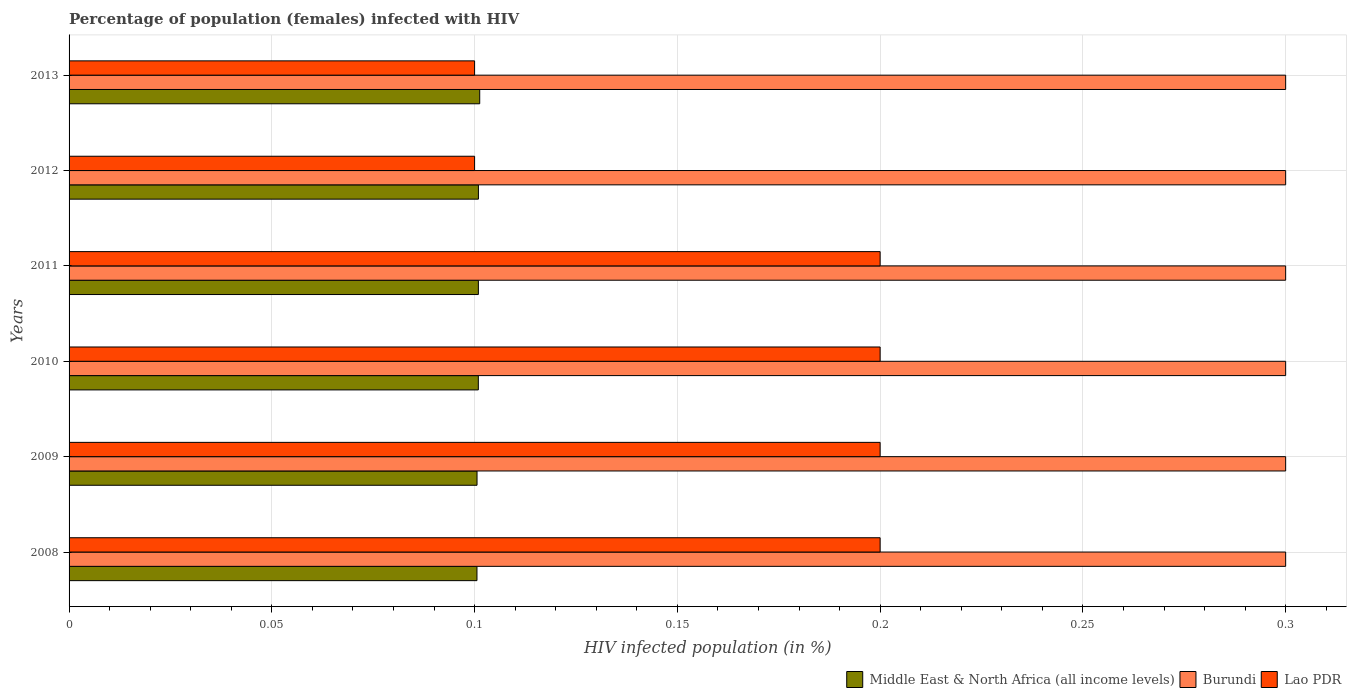Are the number of bars per tick equal to the number of legend labels?
Give a very brief answer. Yes. Are the number of bars on each tick of the Y-axis equal?
Your answer should be compact. Yes. In how many cases, is the number of bars for a given year not equal to the number of legend labels?
Offer a very short reply. 0. What is the percentage of HIV infected female population in Lao PDR in 2011?
Make the answer very short. 0.2. Across all years, what is the maximum percentage of HIV infected female population in Middle East & North Africa (all income levels)?
Your answer should be very brief. 0.1. Across all years, what is the minimum percentage of HIV infected female population in Middle East & North Africa (all income levels)?
Keep it short and to the point. 0.1. In which year was the percentage of HIV infected female population in Lao PDR maximum?
Make the answer very short. 2008. What is the total percentage of HIV infected female population in Middle East & North Africa (all income levels) in the graph?
Make the answer very short. 0.61. What is the difference between the percentage of HIV infected female population in Burundi in 2011 and the percentage of HIV infected female population in Lao PDR in 2008?
Ensure brevity in your answer.  0.1. What is the average percentage of HIV infected female population in Middle East & North Africa (all income levels) per year?
Give a very brief answer. 0.1. In the year 2010, what is the difference between the percentage of HIV infected female population in Burundi and percentage of HIV infected female population in Middle East & North Africa (all income levels)?
Offer a very short reply. 0.2. What is the ratio of the percentage of HIV infected female population in Middle East & North Africa (all income levels) in 2010 to that in 2011?
Make the answer very short. 1. Is the percentage of HIV infected female population in Middle East & North Africa (all income levels) in 2010 less than that in 2012?
Your answer should be compact. Yes. In how many years, is the percentage of HIV infected female population in Lao PDR greater than the average percentage of HIV infected female population in Lao PDR taken over all years?
Offer a terse response. 4. Is the sum of the percentage of HIV infected female population in Middle East & North Africa (all income levels) in 2008 and 2013 greater than the maximum percentage of HIV infected female population in Lao PDR across all years?
Provide a succinct answer. Yes. What does the 1st bar from the top in 2012 represents?
Your answer should be very brief. Lao PDR. What does the 3rd bar from the bottom in 2013 represents?
Make the answer very short. Lao PDR. Are the values on the major ticks of X-axis written in scientific E-notation?
Provide a succinct answer. No. Does the graph contain any zero values?
Offer a very short reply. No. Where does the legend appear in the graph?
Your answer should be compact. Bottom right. What is the title of the graph?
Make the answer very short. Percentage of population (females) infected with HIV. What is the label or title of the X-axis?
Your answer should be compact. HIV infected population (in %). What is the HIV infected population (in %) in Middle East & North Africa (all income levels) in 2008?
Provide a short and direct response. 0.1. What is the HIV infected population (in %) in Middle East & North Africa (all income levels) in 2009?
Your response must be concise. 0.1. What is the HIV infected population (in %) of Middle East & North Africa (all income levels) in 2010?
Provide a short and direct response. 0.1. What is the HIV infected population (in %) in Lao PDR in 2010?
Make the answer very short. 0.2. What is the HIV infected population (in %) in Middle East & North Africa (all income levels) in 2011?
Make the answer very short. 0.1. What is the HIV infected population (in %) of Lao PDR in 2011?
Provide a succinct answer. 0.2. What is the HIV infected population (in %) in Middle East & North Africa (all income levels) in 2012?
Ensure brevity in your answer.  0.1. What is the HIV infected population (in %) of Middle East & North Africa (all income levels) in 2013?
Offer a terse response. 0.1. What is the HIV infected population (in %) of Burundi in 2013?
Provide a succinct answer. 0.3. Across all years, what is the maximum HIV infected population (in %) of Middle East & North Africa (all income levels)?
Your answer should be very brief. 0.1. Across all years, what is the minimum HIV infected population (in %) of Middle East & North Africa (all income levels)?
Give a very brief answer. 0.1. Across all years, what is the minimum HIV infected population (in %) of Burundi?
Keep it short and to the point. 0.3. Across all years, what is the minimum HIV infected population (in %) in Lao PDR?
Provide a short and direct response. 0.1. What is the total HIV infected population (in %) in Middle East & North Africa (all income levels) in the graph?
Provide a succinct answer. 0.61. What is the total HIV infected population (in %) in Lao PDR in the graph?
Offer a terse response. 1. What is the difference between the HIV infected population (in %) of Middle East & North Africa (all income levels) in 2008 and that in 2009?
Make the answer very short. -0. What is the difference between the HIV infected population (in %) in Burundi in 2008 and that in 2009?
Provide a short and direct response. 0. What is the difference between the HIV infected population (in %) in Middle East & North Africa (all income levels) in 2008 and that in 2010?
Your answer should be compact. -0. What is the difference between the HIV infected population (in %) in Burundi in 2008 and that in 2010?
Keep it short and to the point. 0. What is the difference between the HIV infected population (in %) of Lao PDR in 2008 and that in 2010?
Make the answer very short. 0. What is the difference between the HIV infected population (in %) of Middle East & North Africa (all income levels) in 2008 and that in 2011?
Make the answer very short. -0. What is the difference between the HIV infected population (in %) in Middle East & North Africa (all income levels) in 2008 and that in 2012?
Provide a succinct answer. -0. What is the difference between the HIV infected population (in %) in Lao PDR in 2008 and that in 2012?
Make the answer very short. 0.1. What is the difference between the HIV infected population (in %) in Middle East & North Africa (all income levels) in 2008 and that in 2013?
Your answer should be very brief. -0. What is the difference between the HIV infected population (in %) of Burundi in 2008 and that in 2013?
Give a very brief answer. 0. What is the difference between the HIV infected population (in %) of Lao PDR in 2008 and that in 2013?
Your answer should be very brief. 0.1. What is the difference between the HIV infected population (in %) in Middle East & North Africa (all income levels) in 2009 and that in 2010?
Make the answer very short. -0. What is the difference between the HIV infected population (in %) in Burundi in 2009 and that in 2010?
Ensure brevity in your answer.  0. What is the difference between the HIV infected population (in %) in Lao PDR in 2009 and that in 2010?
Give a very brief answer. 0. What is the difference between the HIV infected population (in %) of Middle East & North Africa (all income levels) in 2009 and that in 2011?
Your response must be concise. -0. What is the difference between the HIV infected population (in %) in Middle East & North Africa (all income levels) in 2009 and that in 2012?
Provide a succinct answer. -0. What is the difference between the HIV infected population (in %) in Burundi in 2009 and that in 2012?
Your answer should be compact. 0. What is the difference between the HIV infected population (in %) of Lao PDR in 2009 and that in 2012?
Provide a short and direct response. 0.1. What is the difference between the HIV infected population (in %) of Middle East & North Africa (all income levels) in 2009 and that in 2013?
Your answer should be compact. -0. What is the difference between the HIV infected population (in %) of Burundi in 2009 and that in 2013?
Offer a very short reply. 0. What is the difference between the HIV infected population (in %) of Lao PDR in 2009 and that in 2013?
Give a very brief answer. 0.1. What is the difference between the HIV infected population (in %) in Lao PDR in 2010 and that in 2011?
Provide a succinct answer. 0. What is the difference between the HIV infected population (in %) of Lao PDR in 2010 and that in 2012?
Offer a terse response. 0.1. What is the difference between the HIV infected population (in %) of Middle East & North Africa (all income levels) in 2010 and that in 2013?
Offer a terse response. -0. What is the difference between the HIV infected population (in %) in Burundi in 2010 and that in 2013?
Offer a terse response. 0. What is the difference between the HIV infected population (in %) in Lao PDR in 2011 and that in 2012?
Provide a short and direct response. 0.1. What is the difference between the HIV infected population (in %) of Middle East & North Africa (all income levels) in 2011 and that in 2013?
Your response must be concise. -0. What is the difference between the HIV infected population (in %) of Burundi in 2011 and that in 2013?
Offer a very short reply. 0. What is the difference between the HIV infected population (in %) of Lao PDR in 2011 and that in 2013?
Ensure brevity in your answer.  0.1. What is the difference between the HIV infected population (in %) in Middle East & North Africa (all income levels) in 2012 and that in 2013?
Your answer should be compact. -0. What is the difference between the HIV infected population (in %) in Lao PDR in 2012 and that in 2013?
Provide a succinct answer. 0. What is the difference between the HIV infected population (in %) of Middle East & North Africa (all income levels) in 2008 and the HIV infected population (in %) of Burundi in 2009?
Provide a succinct answer. -0.2. What is the difference between the HIV infected population (in %) of Middle East & North Africa (all income levels) in 2008 and the HIV infected population (in %) of Lao PDR in 2009?
Give a very brief answer. -0.1. What is the difference between the HIV infected population (in %) in Middle East & North Africa (all income levels) in 2008 and the HIV infected population (in %) in Burundi in 2010?
Make the answer very short. -0.2. What is the difference between the HIV infected population (in %) in Middle East & North Africa (all income levels) in 2008 and the HIV infected population (in %) in Lao PDR in 2010?
Offer a very short reply. -0.1. What is the difference between the HIV infected population (in %) of Middle East & North Africa (all income levels) in 2008 and the HIV infected population (in %) of Burundi in 2011?
Offer a very short reply. -0.2. What is the difference between the HIV infected population (in %) of Middle East & North Africa (all income levels) in 2008 and the HIV infected population (in %) of Lao PDR in 2011?
Give a very brief answer. -0.1. What is the difference between the HIV infected population (in %) in Burundi in 2008 and the HIV infected population (in %) in Lao PDR in 2011?
Your response must be concise. 0.1. What is the difference between the HIV infected population (in %) in Middle East & North Africa (all income levels) in 2008 and the HIV infected population (in %) in Burundi in 2012?
Offer a very short reply. -0.2. What is the difference between the HIV infected population (in %) of Middle East & North Africa (all income levels) in 2008 and the HIV infected population (in %) of Lao PDR in 2012?
Offer a terse response. 0. What is the difference between the HIV infected population (in %) of Middle East & North Africa (all income levels) in 2008 and the HIV infected population (in %) of Burundi in 2013?
Provide a short and direct response. -0.2. What is the difference between the HIV infected population (in %) of Middle East & North Africa (all income levels) in 2008 and the HIV infected population (in %) of Lao PDR in 2013?
Give a very brief answer. 0. What is the difference between the HIV infected population (in %) in Middle East & North Africa (all income levels) in 2009 and the HIV infected population (in %) in Burundi in 2010?
Your answer should be very brief. -0.2. What is the difference between the HIV infected population (in %) in Middle East & North Africa (all income levels) in 2009 and the HIV infected population (in %) in Lao PDR in 2010?
Make the answer very short. -0.1. What is the difference between the HIV infected population (in %) of Burundi in 2009 and the HIV infected population (in %) of Lao PDR in 2010?
Offer a very short reply. 0.1. What is the difference between the HIV infected population (in %) in Middle East & North Africa (all income levels) in 2009 and the HIV infected population (in %) in Burundi in 2011?
Make the answer very short. -0.2. What is the difference between the HIV infected population (in %) in Middle East & North Africa (all income levels) in 2009 and the HIV infected population (in %) in Lao PDR in 2011?
Your response must be concise. -0.1. What is the difference between the HIV infected population (in %) in Middle East & North Africa (all income levels) in 2009 and the HIV infected population (in %) in Burundi in 2012?
Give a very brief answer. -0.2. What is the difference between the HIV infected population (in %) of Middle East & North Africa (all income levels) in 2009 and the HIV infected population (in %) of Lao PDR in 2012?
Your answer should be compact. 0. What is the difference between the HIV infected population (in %) of Middle East & North Africa (all income levels) in 2009 and the HIV infected population (in %) of Burundi in 2013?
Offer a terse response. -0.2. What is the difference between the HIV infected population (in %) of Middle East & North Africa (all income levels) in 2009 and the HIV infected population (in %) of Lao PDR in 2013?
Your answer should be compact. 0. What is the difference between the HIV infected population (in %) in Burundi in 2009 and the HIV infected population (in %) in Lao PDR in 2013?
Your answer should be very brief. 0.2. What is the difference between the HIV infected population (in %) in Middle East & North Africa (all income levels) in 2010 and the HIV infected population (in %) in Burundi in 2011?
Give a very brief answer. -0.2. What is the difference between the HIV infected population (in %) in Middle East & North Africa (all income levels) in 2010 and the HIV infected population (in %) in Lao PDR in 2011?
Offer a very short reply. -0.1. What is the difference between the HIV infected population (in %) of Burundi in 2010 and the HIV infected population (in %) of Lao PDR in 2011?
Give a very brief answer. 0.1. What is the difference between the HIV infected population (in %) in Middle East & North Africa (all income levels) in 2010 and the HIV infected population (in %) in Burundi in 2012?
Provide a short and direct response. -0.2. What is the difference between the HIV infected population (in %) of Middle East & North Africa (all income levels) in 2010 and the HIV infected population (in %) of Lao PDR in 2012?
Provide a short and direct response. 0. What is the difference between the HIV infected population (in %) in Middle East & North Africa (all income levels) in 2010 and the HIV infected population (in %) in Burundi in 2013?
Provide a short and direct response. -0.2. What is the difference between the HIV infected population (in %) in Middle East & North Africa (all income levels) in 2010 and the HIV infected population (in %) in Lao PDR in 2013?
Provide a succinct answer. 0. What is the difference between the HIV infected population (in %) of Middle East & North Africa (all income levels) in 2011 and the HIV infected population (in %) of Burundi in 2012?
Offer a very short reply. -0.2. What is the difference between the HIV infected population (in %) of Middle East & North Africa (all income levels) in 2011 and the HIV infected population (in %) of Lao PDR in 2012?
Ensure brevity in your answer.  0. What is the difference between the HIV infected population (in %) in Middle East & North Africa (all income levels) in 2011 and the HIV infected population (in %) in Burundi in 2013?
Your response must be concise. -0.2. What is the difference between the HIV infected population (in %) in Middle East & North Africa (all income levels) in 2011 and the HIV infected population (in %) in Lao PDR in 2013?
Offer a very short reply. 0. What is the difference between the HIV infected population (in %) of Burundi in 2011 and the HIV infected population (in %) of Lao PDR in 2013?
Provide a succinct answer. 0.2. What is the difference between the HIV infected population (in %) of Middle East & North Africa (all income levels) in 2012 and the HIV infected population (in %) of Burundi in 2013?
Your answer should be compact. -0.2. What is the difference between the HIV infected population (in %) of Middle East & North Africa (all income levels) in 2012 and the HIV infected population (in %) of Lao PDR in 2013?
Make the answer very short. 0. What is the average HIV infected population (in %) in Middle East & North Africa (all income levels) per year?
Provide a short and direct response. 0.1. What is the average HIV infected population (in %) in Lao PDR per year?
Provide a short and direct response. 0.17. In the year 2008, what is the difference between the HIV infected population (in %) in Middle East & North Africa (all income levels) and HIV infected population (in %) in Burundi?
Offer a terse response. -0.2. In the year 2008, what is the difference between the HIV infected population (in %) of Middle East & North Africa (all income levels) and HIV infected population (in %) of Lao PDR?
Provide a short and direct response. -0.1. In the year 2009, what is the difference between the HIV infected population (in %) of Middle East & North Africa (all income levels) and HIV infected population (in %) of Burundi?
Provide a short and direct response. -0.2. In the year 2009, what is the difference between the HIV infected population (in %) of Middle East & North Africa (all income levels) and HIV infected population (in %) of Lao PDR?
Provide a short and direct response. -0.1. In the year 2009, what is the difference between the HIV infected population (in %) in Burundi and HIV infected population (in %) in Lao PDR?
Make the answer very short. 0.1. In the year 2010, what is the difference between the HIV infected population (in %) of Middle East & North Africa (all income levels) and HIV infected population (in %) of Burundi?
Give a very brief answer. -0.2. In the year 2010, what is the difference between the HIV infected population (in %) in Middle East & North Africa (all income levels) and HIV infected population (in %) in Lao PDR?
Keep it short and to the point. -0.1. In the year 2011, what is the difference between the HIV infected population (in %) of Middle East & North Africa (all income levels) and HIV infected population (in %) of Burundi?
Ensure brevity in your answer.  -0.2. In the year 2011, what is the difference between the HIV infected population (in %) of Middle East & North Africa (all income levels) and HIV infected population (in %) of Lao PDR?
Keep it short and to the point. -0.1. In the year 2011, what is the difference between the HIV infected population (in %) of Burundi and HIV infected population (in %) of Lao PDR?
Offer a very short reply. 0.1. In the year 2012, what is the difference between the HIV infected population (in %) in Middle East & North Africa (all income levels) and HIV infected population (in %) in Burundi?
Ensure brevity in your answer.  -0.2. In the year 2012, what is the difference between the HIV infected population (in %) in Middle East & North Africa (all income levels) and HIV infected population (in %) in Lao PDR?
Keep it short and to the point. 0. In the year 2013, what is the difference between the HIV infected population (in %) of Middle East & North Africa (all income levels) and HIV infected population (in %) of Burundi?
Offer a very short reply. -0.2. In the year 2013, what is the difference between the HIV infected population (in %) of Middle East & North Africa (all income levels) and HIV infected population (in %) of Lao PDR?
Make the answer very short. 0. What is the ratio of the HIV infected population (in %) of Middle East & North Africa (all income levels) in 2008 to that in 2009?
Provide a short and direct response. 1. What is the ratio of the HIV infected population (in %) in Burundi in 2008 to that in 2009?
Give a very brief answer. 1. What is the ratio of the HIV infected population (in %) of Middle East & North Africa (all income levels) in 2008 to that in 2010?
Ensure brevity in your answer.  1. What is the ratio of the HIV infected population (in %) of Burundi in 2008 to that in 2010?
Your answer should be very brief. 1. What is the ratio of the HIV infected population (in %) in Lao PDR in 2008 to that in 2011?
Make the answer very short. 1. What is the ratio of the HIV infected population (in %) of Lao PDR in 2008 to that in 2012?
Provide a short and direct response. 2. What is the ratio of the HIV infected population (in %) in Burundi in 2008 to that in 2013?
Your response must be concise. 1. What is the ratio of the HIV infected population (in %) of Lao PDR in 2008 to that in 2013?
Offer a very short reply. 2. What is the ratio of the HIV infected population (in %) of Lao PDR in 2009 to that in 2010?
Give a very brief answer. 1. What is the ratio of the HIV infected population (in %) in Middle East & North Africa (all income levels) in 2009 to that in 2012?
Provide a succinct answer. 1. What is the ratio of the HIV infected population (in %) in Burundi in 2009 to that in 2012?
Ensure brevity in your answer.  1. What is the ratio of the HIV infected population (in %) of Middle East & North Africa (all income levels) in 2009 to that in 2013?
Your answer should be compact. 0.99. What is the ratio of the HIV infected population (in %) in Burundi in 2009 to that in 2013?
Provide a succinct answer. 1. What is the ratio of the HIV infected population (in %) in Lao PDR in 2009 to that in 2013?
Ensure brevity in your answer.  2. What is the ratio of the HIV infected population (in %) of Middle East & North Africa (all income levels) in 2010 to that in 2011?
Provide a succinct answer. 1. What is the ratio of the HIV infected population (in %) of Burundi in 2010 to that in 2011?
Provide a short and direct response. 1. What is the ratio of the HIV infected population (in %) of Lao PDR in 2010 to that in 2011?
Provide a short and direct response. 1. What is the ratio of the HIV infected population (in %) in Burundi in 2010 to that in 2012?
Keep it short and to the point. 1. What is the ratio of the HIV infected population (in %) in Lao PDR in 2010 to that in 2012?
Ensure brevity in your answer.  2. What is the ratio of the HIV infected population (in %) of Burundi in 2010 to that in 2013?
Provide a succinct answer. 1. What is the ratio of the HIV infected population (in %) in Lao PDR in 2010 to that in 2013?
Offer a very short reply. 2. What is the ratio of the HIV infected population (in %) in Middle East & North Africa (all income levels) in 2011 to that in 2012?
Give a very brief answer. 1. What is the ratio of the HIV infected population (in %) of Burundi in 2011 to that in 2012?
Give a very brief answer. 1. What is the ratio of the HIV infected population (in %) of Lao PDR in 2011 to that in 2012?
Offer a very short reply. 2. What is the difference between the highest and the second highest HIV infected population (in %) in Middle East & North Africa (all income levels)?
Keep it short and to the point. 0. What is the difference between the highest and the second highest HIV infected population (in %) of Burundi?
Give a very brief answer. 0. What is the difference between the highest and the lowest HIV infected population (in %) of Middle East & North Africa (all income levels)?
Ensure brevity in your answer.  0. What is the difference between the highest and the lowest HIV infected population (in %) in Burundi?
Make the answer very short. 0. 